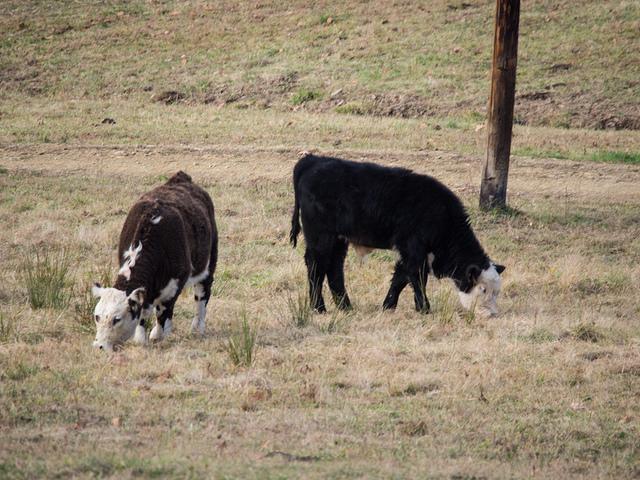How many cattle are on the field?
Write a very short answer. 2. Is this a bull or cow?
Keep it brief. Cow. What are the cows doing?
Answer briefly. Grazing. What color are the cows?
Keep it brief. Black and white. What is behind the cows?
Short answer required. Grass. What is the likely purpose of the pole?
Be succinct. Electricity. 